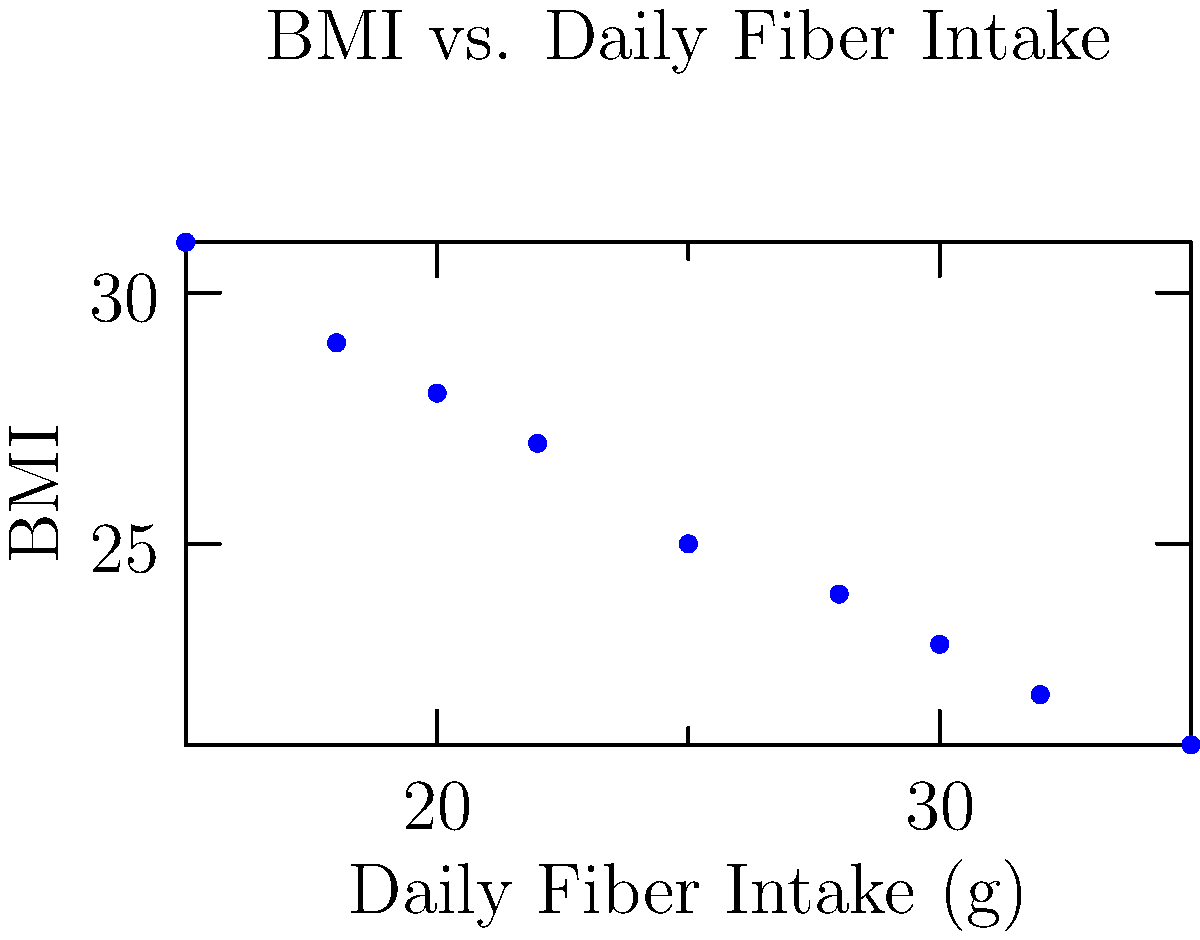Based on the scatter plot showing the relationship between daily fiber intake and BMI, what is the approximate BMI for an individual with a daily fiber intake of 25 grams? To answer this question, we need to follow these steps:

1. Locate the point on the x-axis that corresponds to 25 grams of daily fiber intake.
2. Move vertically from this point until we intersect with the general trend of the data points.
3. Read the corresponding BMI value on the y-axis.

Looking at the scatter plot:

1. We find 25 on the x-axis (Daily Fiber Intake).
2. Moving vertically up from 25, we see that this line would intersect with the trend of the data points at approximately the middle of the plot.
3. Reading the y-axis (BMI) value for this point, we can estimate that it's close to 25.

The scatter plot shows a negative correlation between daily fiber intake and BMI, meaning that as fiber intake increases, BMI tends to decrease. This aligns with the health benefits of a high-fiber diet, which is particularly relevant for someone managing a chronic condition through nutrition.
Answer: 25 